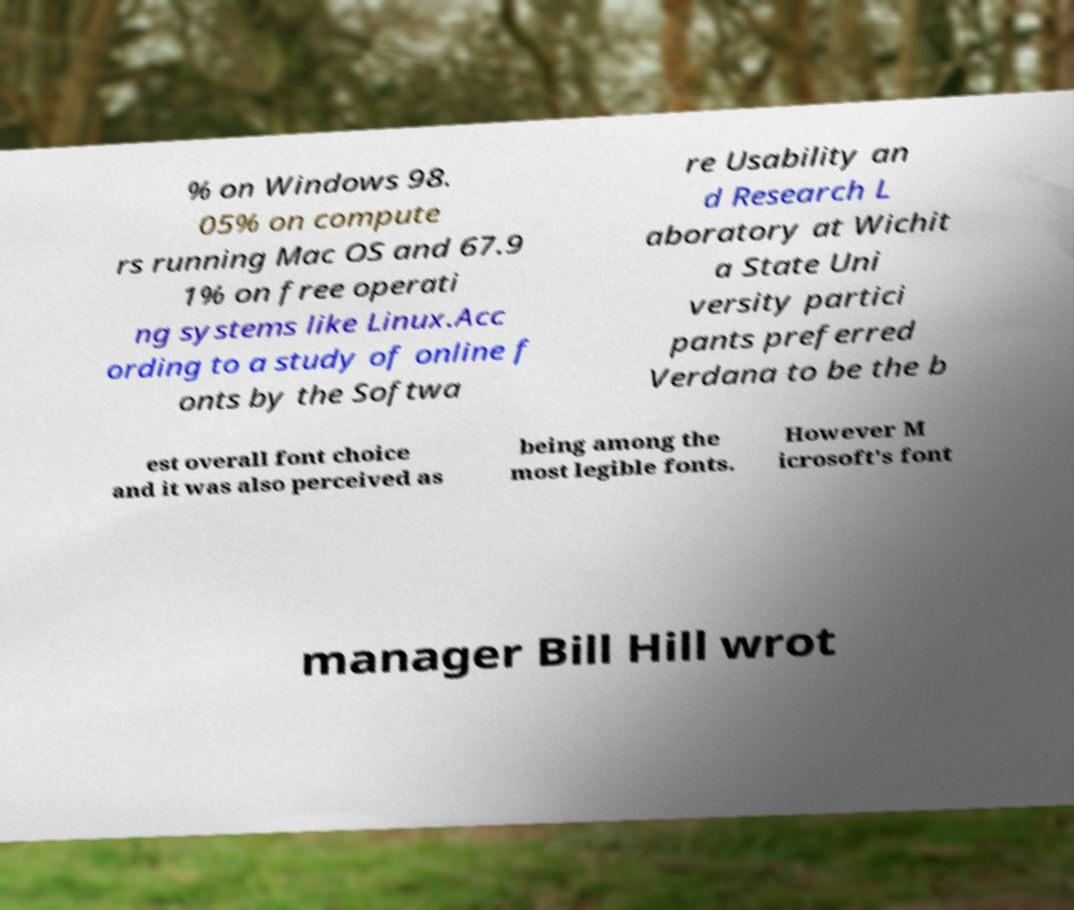What messages or text are displayed in this image? I need them in a readable, typed format. % on Windows 98. 05% on compute rs running Mac OS and 67.9 1% on free operati ng systems like Linux.Acc ording to a study of online f onts by the Softwa re Usability an d Research L aboratory at Wichit a State Uni versity partici pants preferred Verdana to be the b est overall font choice and it was also perceived as being among the most legible fonts. However M icrosoft's font manager Bill Hill wrot 